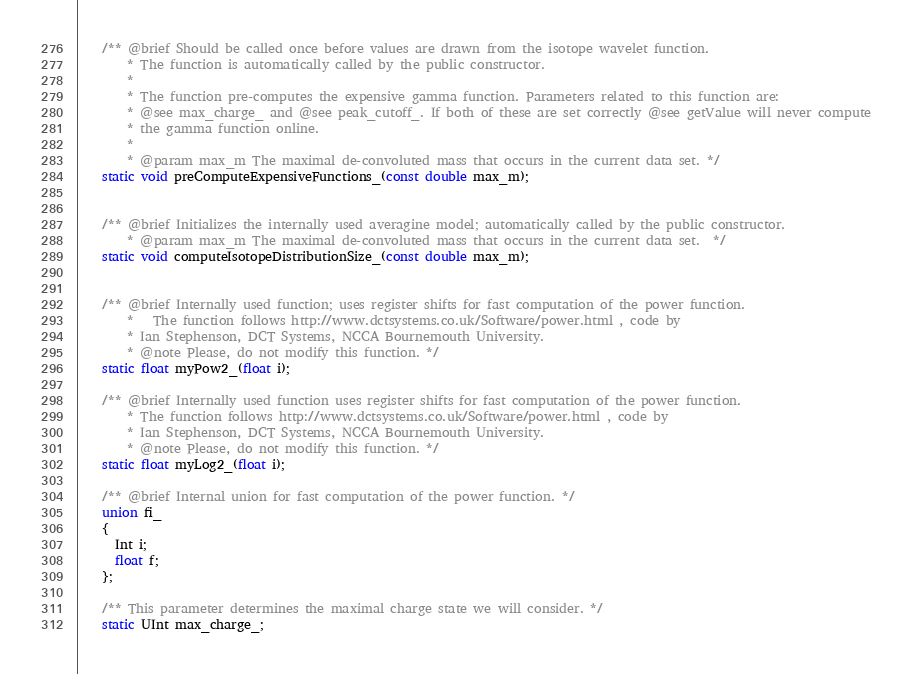<code> <loc_0><loc_0><loc_500><loc_500><_C_>

    /** @brief Should be called once before values are drawn from the isotope wavelet function.
        * The function is automatically called by the public constructor.
        *
        * The function pre-computes the expensive gamma function. Parameters related to this function are:
        * @see max_charge_ and @see peak_cutoff_. If both of these are set correctly @see getValue will never compute
        * the gamma function online.
        *
        * @param max_m The maximal de-convoluted mass that occurs in the current data set. */
    static void preComputeExpensiveFunctions_(const double max_m);


    /** @brief Initializes the internally used averagine model; automatically called by the public constructor.
        * @param max_m The maximal de-convoluted mass that occurs in the current data set.	*/
    static void computeIsotopeDistributionSize_(const double max_m);


    /** @brief Internally used function; uses register shifts for fast computation of the power function.
        *	The function follows http://www.dctsystems.co.uk/Software/power.html , code by
        * Ian Stephenson, DCT Systems, NCCA Bournemouth University.
        * @note Please, do not modify this function. */
    static float myPow2_(float i);

    /** @brief Internally used function uses register shifts for fast computation of the power function.
        * The function follows http://www.dctsystems.co.uk/Software/power.html , code by
        * Ian Stephenson, DCT Systems, NCCA Bournemouth University.
        * @note Please, do not modify this function. */
    static float myLog2_(float i);

    /** @brief Internal union for fast computation of the power function. */
    union fi_
    {
      Int i;
      float f;
    };

    /** This parameter determines the maximal charge state we will consider. */
    static UInt max_charge_;
</code> 